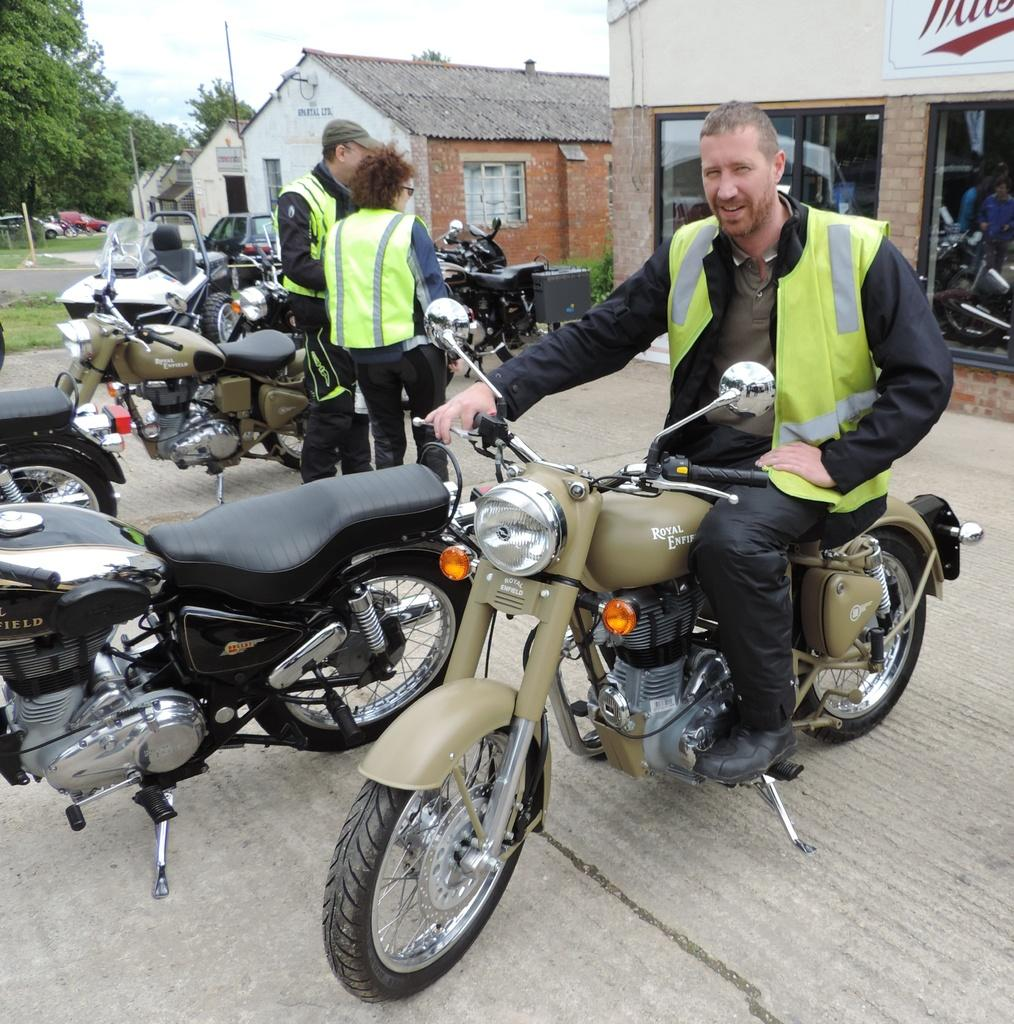How many people are present in the image? There are two people standing in the image. What is the man in the image doing? The man is seated on a motorcycle. What type of structures can be seen in the image? There are houses visible in the image. What type of vegetation is visible in the image? There are trees visible in the image. How many motorcycles are parked in the image? There are motorcycles parked in the image. What type of spoon is the man using to eat his trousers in the image? There is no spoon or trousers present in the image, and the man is seated on a motorcycle, not eating anything. What color is the cap that the woman is wearing in the image? There is no woman or cap present in the image; only two people and a man seated on a motorcycle are visible. 